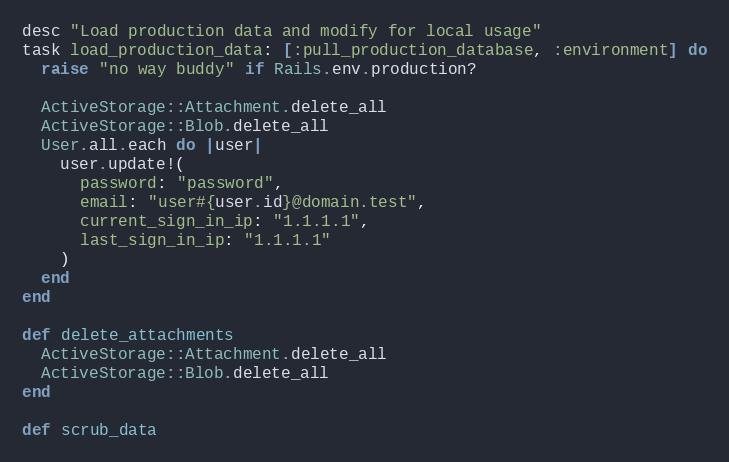Convert code to text. <code><loc_0><loc_0><loc_500><loc_500><_Ruby_>desc "Load production data and modify for local usage"
task load_production_data: [:pull_production_database, :environment] do
  raise "no way buddy" if Rails.env.production?

  ActiveStorage::Attachment.delete_all
  ActiveStorage::Blob.delete_all
  User.all.each do |user|
    user.update!(
      password: "password",
      email: "user#{user.id}@domain.test",
      current_sign_in_ip: "1.1.1.1",
      last_sign_in_ip: "1.1.1.1"
    )
  end
end

def delete_attachments
  ActiveStorage::Attachment.delete_all
  ActiveStorage::Blob.delete_all
end

def scrub_data</code> 